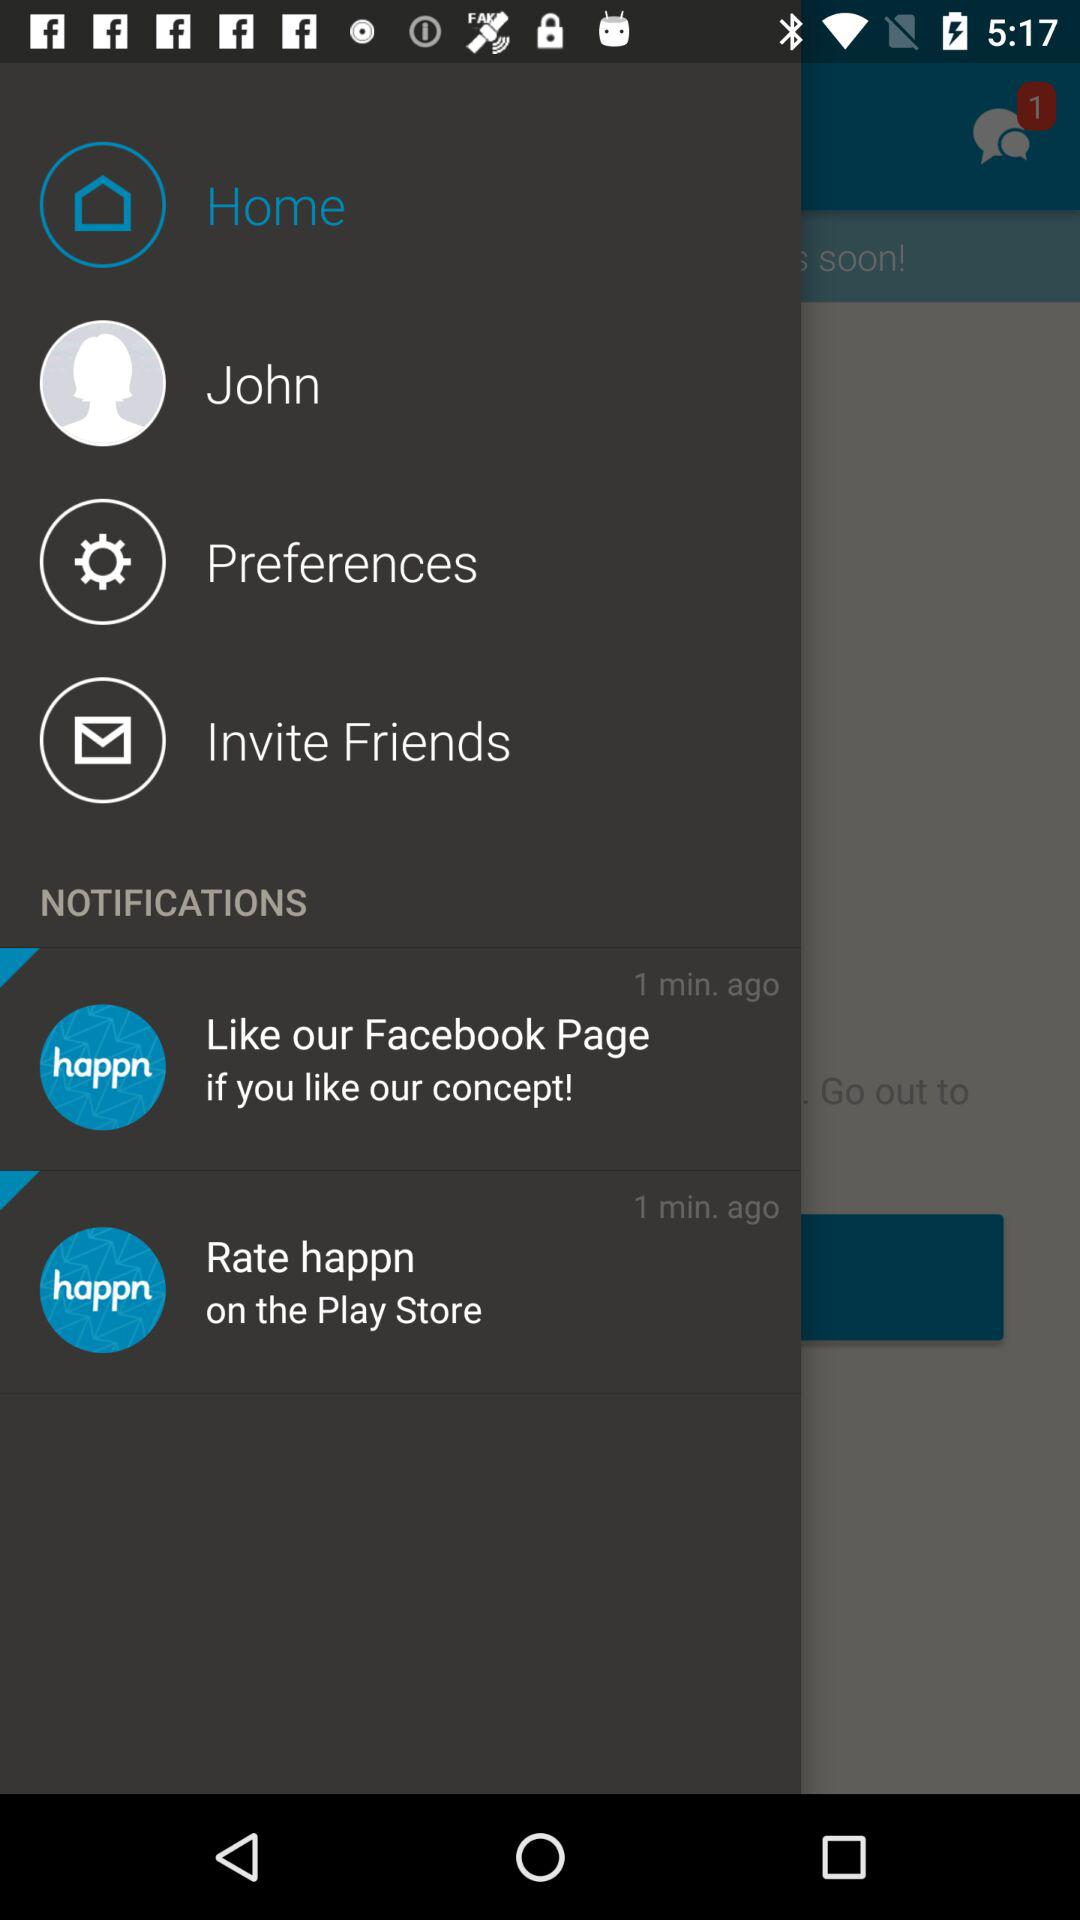How many items have the text '1 min. ago'?
Answer the question using a single word or phrase. 2 